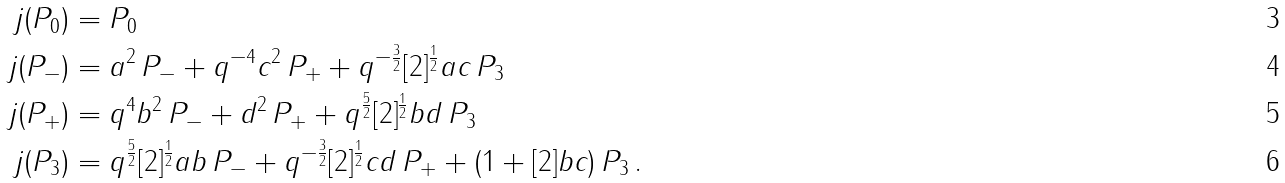<formula> <loc_0><loc_0><loc_500><loc_500>j ( P _ { 0 } ) & = P _ { 0 } \\ j ( P _ { - } ) & = a ^ { 2 } \, P _ { - } + q ^ { - 4 } c ^ { 2 } \, P _ { + } + q ^ { - \frac { 3 } { 2 } } [ 2 ] ^ { \frac { 1 } { 2 } } a c \, P _ { 3 } \\ j ( P _ { + } ) & = q ^ { 4 } b ^ { 2 } \, P _ { - } + d ^ { 2 } \, P _ { + } + q ^ { \frac { 5 } { 2 } } [ 2 ] ^ { \frac { 1 } { 2 } } b d \, P _ { 3 } \\ j ( P _ { 3 } ) & = q ^ { \frac { 5 } { 2 } } [ 2 ] ^ { \frac { 1 } { 2 } } a b \, P _ { - } + q ^ { - \frac { 3 } { 2 } } [ 2 ] ^ { \frac { 1 } { 2 } } c d \, P _ { + } + ( 1 + [ 2 ] b c ) \, P _ { 3 } \, .</formula> 